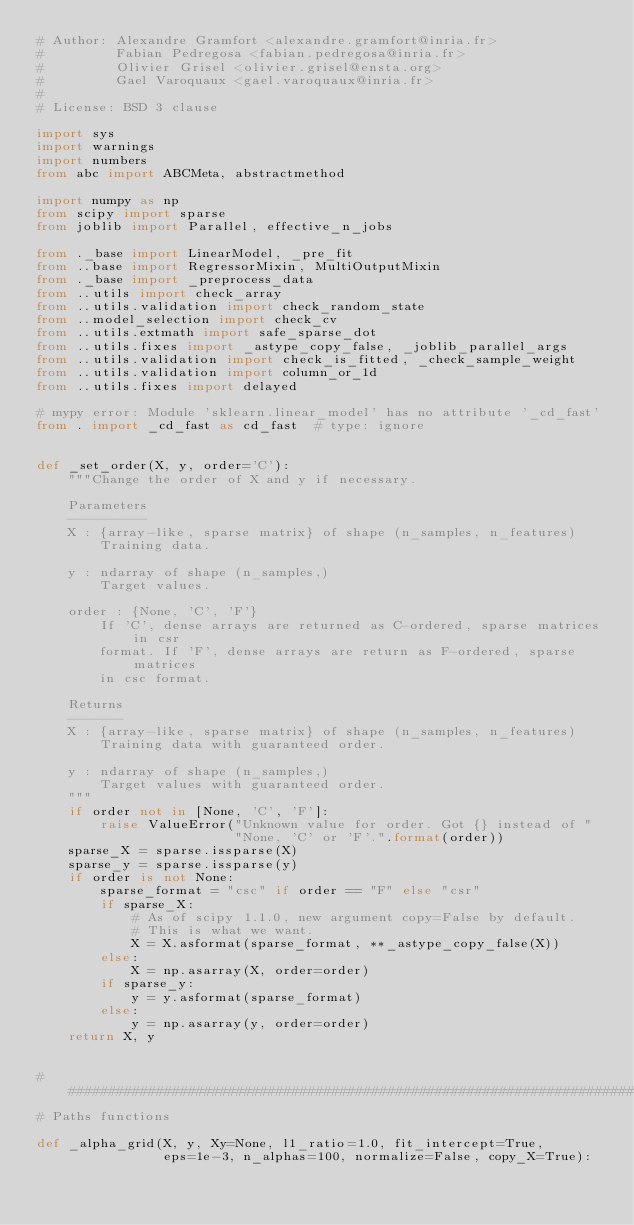<code> <loc_0><loc_0><loc_500><loc_500><_Python_># Author: Alexandre Gramfort <alexandre.gramfort@inria.fr>
#         Fabian Pedregosa <fabian.pedregosa@inria.fr>
#         Olivier Grisel <olivier.grisel@ensta.org>
#         Gael Varoquaux <gael.varoquaux@inria.fr>
#
# License: BSD 3 clause

import sys
import warnings
import numbers
from abc import ABCMeta, abstractmethod

import numpy as np
from scipy import sparse
from joblib import Parallel, effective_n_jobs

from ._base import LinearModel, _pre_fit
from ..base import RegressorMixin, MultiOutputMixin
from ._base import _preprocess_data
from ..utils import check_array
from ..utils.validation import check_random_state
from ..model_selection import check_cv
from ..utils.extmath import safe_sparse_dot
from ..utils.fixes import _astype_copy_false, _joblib_parallel_args
from ..utils.validation import check_is_fitted, _check_sample_weight
from ..utils.validation import column_or_1d
from ..utils.fixes import delayed

# mypy error: Module 'sklearn.linear_model' has no attribute '_cd_fast'
from . import _cd_fast as cd_fast  # type: ignore


def _set_order(X, y, order='C'):
    """Change the order of X and y if necessary.

    Parameters
    ----------
    X : {array-like, sparse matrix} of shape (n_samples, n_features)
        Training data.

    y : ndarray of shape (n_samples,)
        Target values.

    order : {None, 'C', 'F'}
        If 'C', dense arrays are returned as C-ordered, sparse matrices in csr
        format. If 'F', dense arrays are return as F-ordered, sparse matrices
        in csc format.

    Returns
    -------
    X : {array-like, sparse matrix} of shape (n_samples, n_features)
        Training data with guaranteed order.

    y : ndarray of shape (n_samples,)
        Target values with guaranteed order.
    """
    if order not in [None, 'C', 'F']:
        raise ValueError("Unknown value for order. Got {} instead of "
                         "None, 'C' or 'F'.".format(order))
    sparse_X = sparse.issparse(X)
    sparse_y = sparse.issparse(y)
    if order is not None:
        sparse_format = "csc" if order == "F" else "csr"
        if sparse_X:
            # As of scipy 1.1.0, new argument copy=False by default.
            # This is what we want.
            X = X.asformat(sparse_format, **_astype_copy_false(X))
        else:
            X = np.asarray(X, order=order)
        if sparse_y:
            y = y.asformat(sparse_format)
        else:
            y = np.asarray(y, order=order)
    return X, y


###############################################################################
# Paths functions

def _alpha_grid(X, y, Xy=None, l1_ratio=1.0, fit_intercept=True,
                eps=1e-3, n_alphas=100, normalize=False, copy_X=True):</code> 